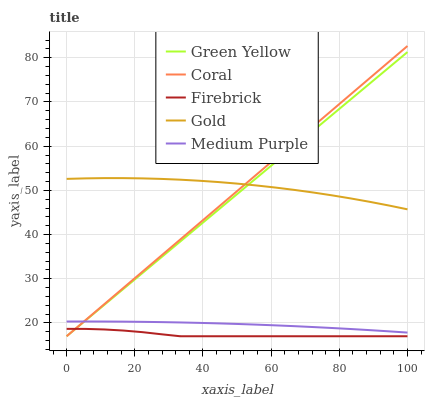Does Coral have the minimum area under the curve?
Answer yes or no. No. Does Coral have the maximum area under the curve?
Answer yes or no. No. Is Green Yellow the smoothest?
Answer yes or no. No. Is Green Yellow the roughest?
Answer yes or no. No. Does Gold have the lowest value?
Answer yes or no. No. Does Green Yellow have the highest value?
Answer yes or no. No. Is Firebrick less than Medium Purple?
Answer yes or no. Yes. Is Gold greater than Firebrick?
Answer yes or no. Yes. Does Firebrick intersect Medium Purple?
Answer yes or no. No. 